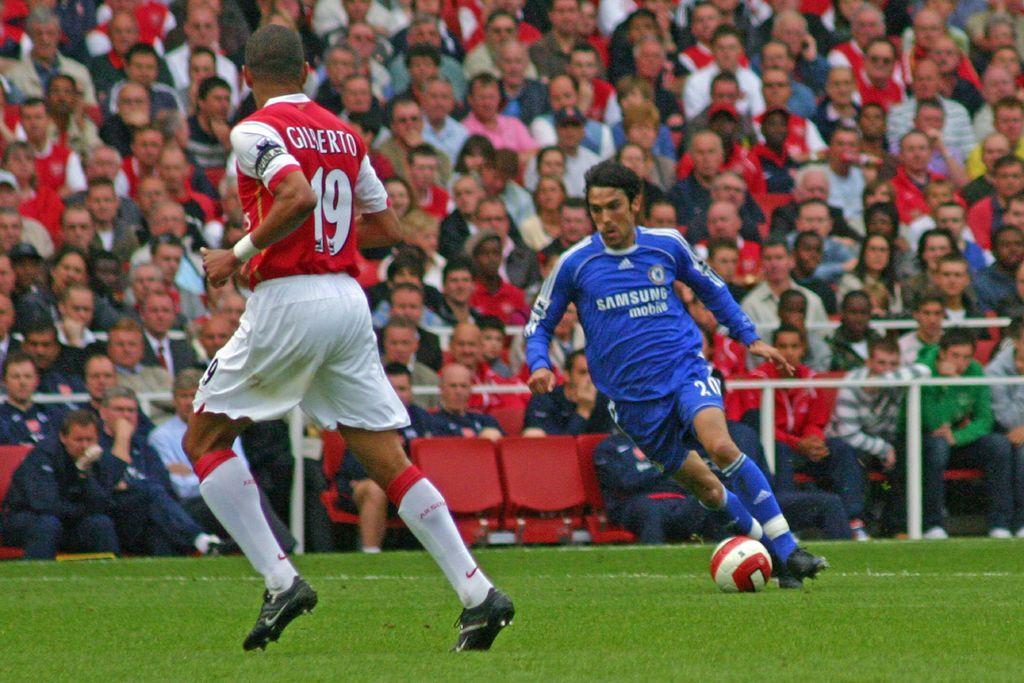How would you summarize this image in a sentence or two? In this picture we can see two men running on ground and we have a ball on ground and in the background we can see a group of people sitting on chairs and looking at this two men. 